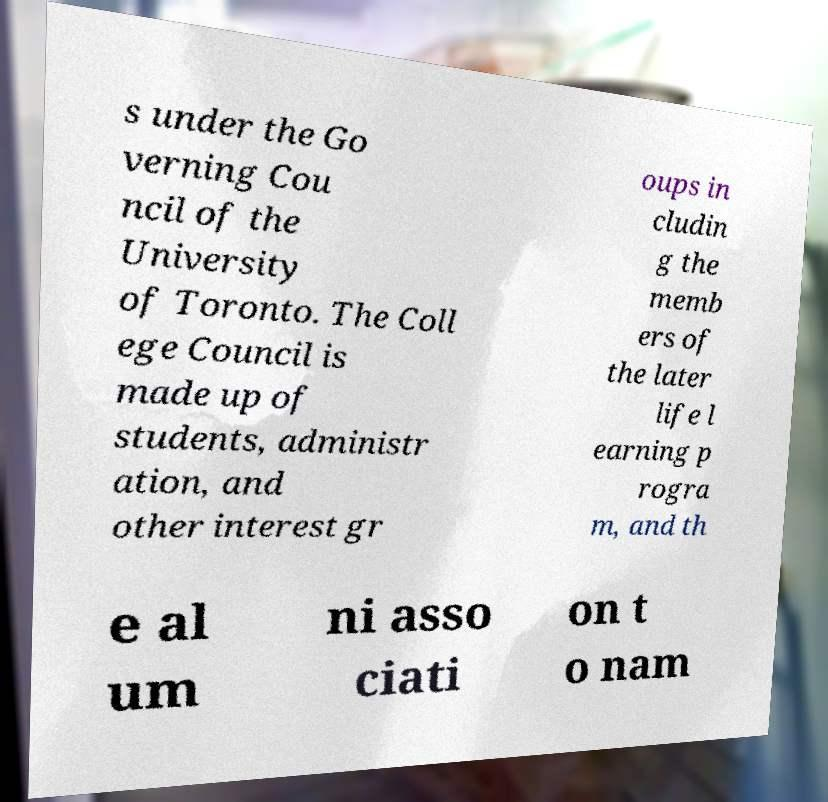What messages or text are displayed in this image? I need them in a readable, typed format. s under the Go verning Cou ncil of the University of Toronto. The Coll ege Council is made up of students, administr ation, and other interest gr oups in cludin g the memb ers of the later life l earning p rogra m, and th e al um ni asso ciati on t o nam 